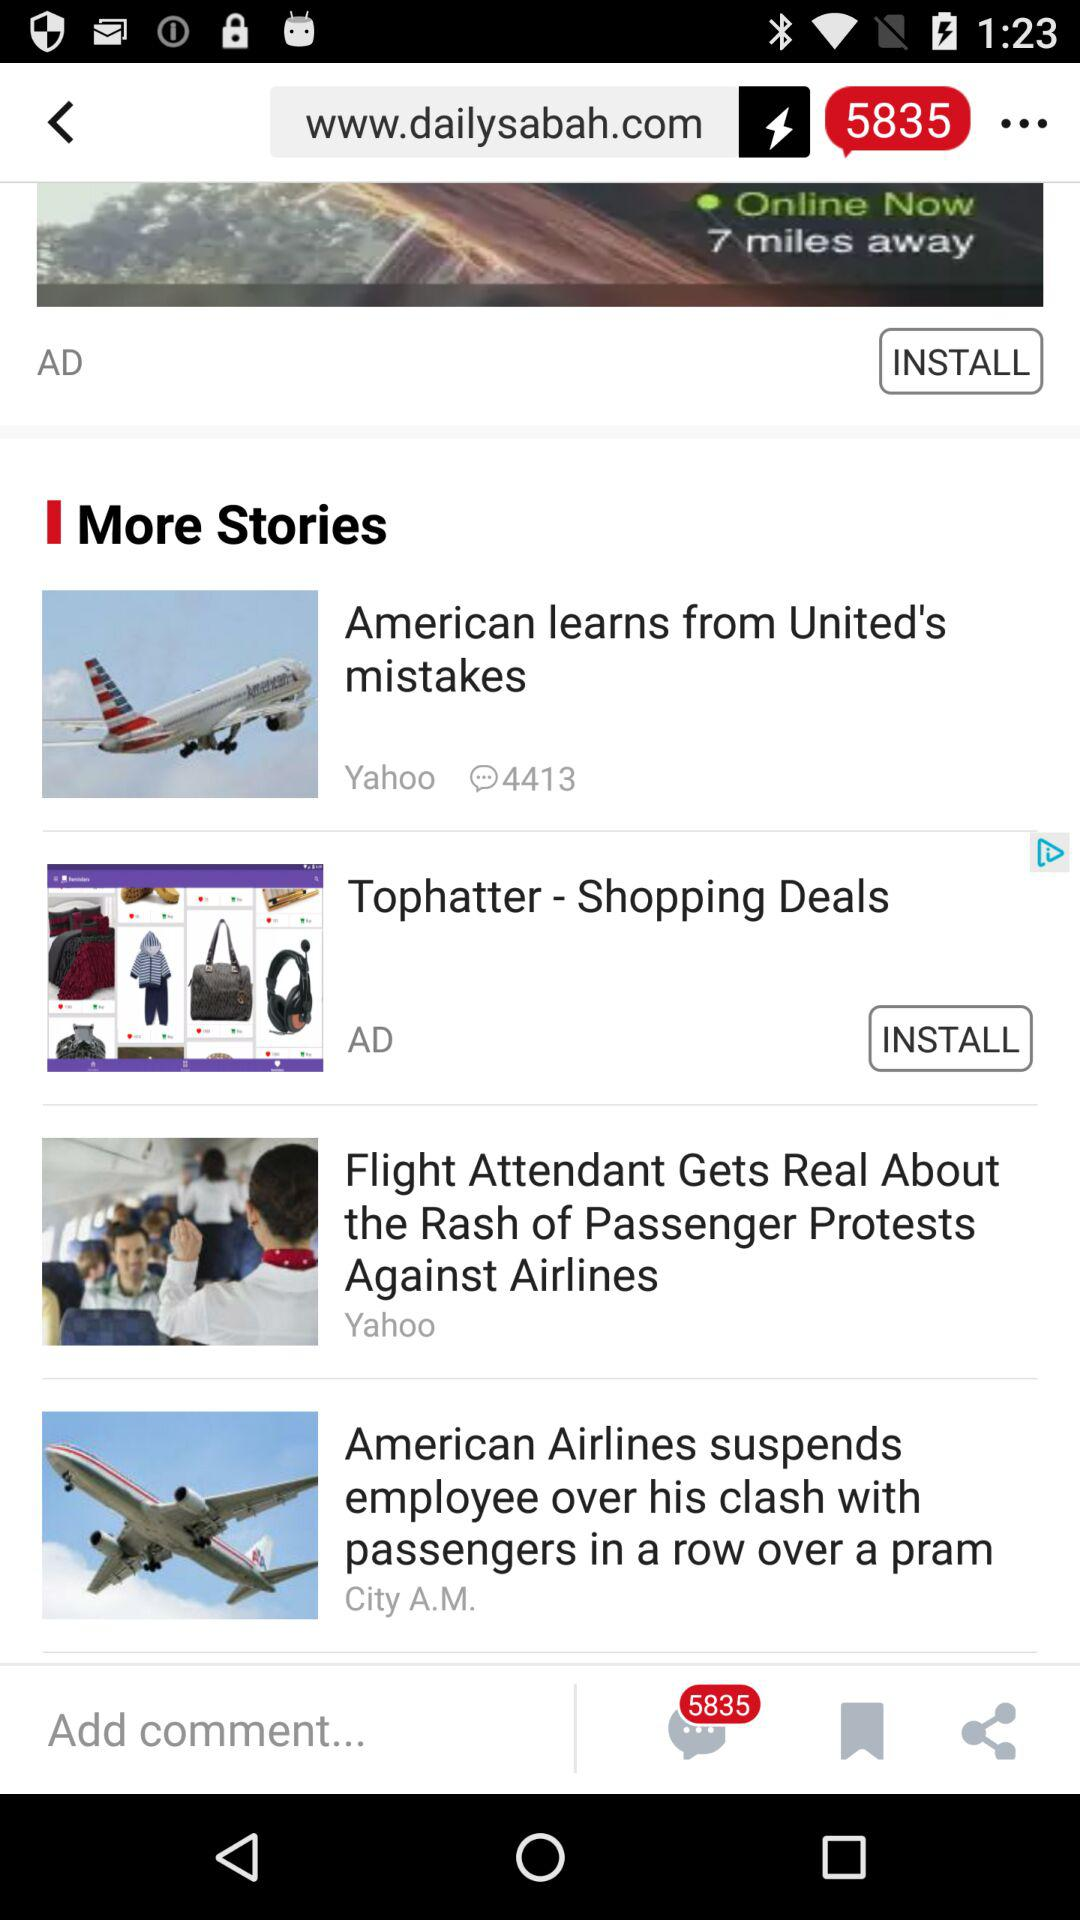How many comments are there on the story? There are 4413 comments. 